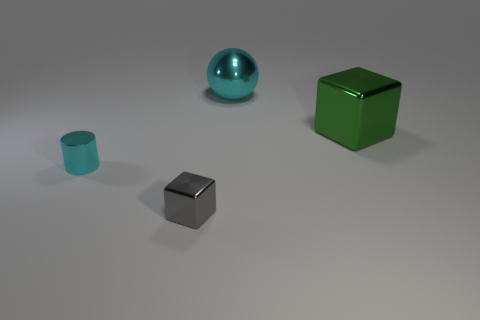There is a cyan shiny sphere behind the cube right of the large sphere; how many small gray objects are in front of it?
Make the answer very short. 1. How many things are behind the green shiny block and in front of the big green cube?
Keep it short and to the point. 0. Are there more shiny cubes that are behind the tiny gray shiny block than small green cubes?
Make the answer very short. Yes. How many other objects have the same size as the gray object?
Provide a succinct answer. 1. What size is the sphere that is the same color as the cylinder?
Your answer should be very brief. Large. What number of tiny objects are cylinders or shiny spheres?
Offer a very short reply. 1. What number of small blue metal blocks are there?
Keep it short and to the point. 0. Are there the same number of small cyan metal cylinders that are to the right of the big cyan metallic object and tiny cyan things that are in front of the big green metallic block?
Ensure brevity in your answer.  No. Are there any small cyan objects in front of the metallic cylinder?
Provide a succinct answer. No. There is a small thing that is to the left of the tiny gray metallic object; what is its color?
Your answer should be very brief. Cyan. 